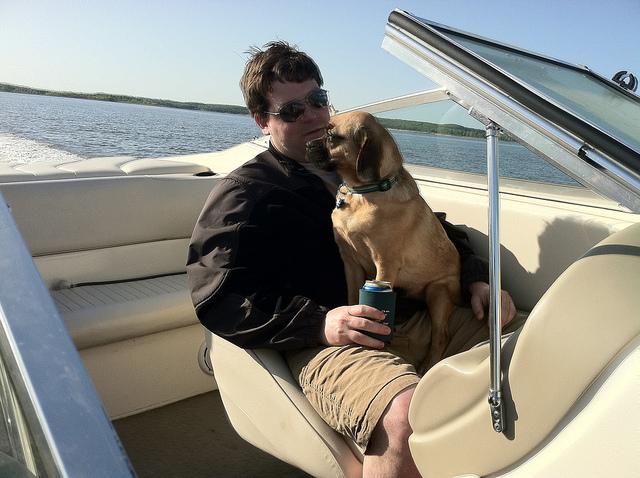Is it likely that the man's beverage is alcoholic?
Be succinct. Yes. What is on the man's face?
Concise answer only. Sunglasses. Is the animal preparing to conduct a search and rescue operation?
Answer briefly. No. 